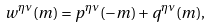Convert formula to latex. <formula><loc_0><loc_0><loc_500><loc_500>w ^ { \eta \nu } ( m ) = p ^ { \eta \nu } ( - m ) + q ^ { \eta \nu } ( m ) ,</formula> 